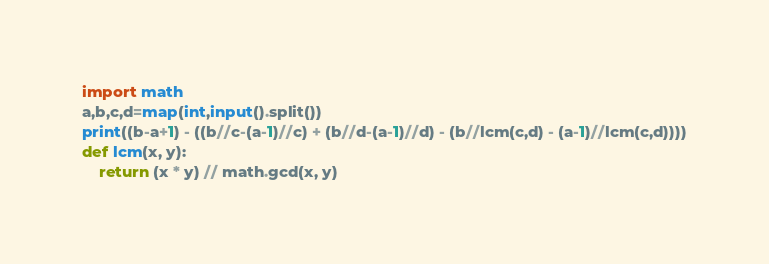<code> <loc_0><loc_0><loc_500><loc_500><_Python_>import math
a,b,c,d=map(int,input().split())
print((b-a+1) - ((b//c-(a-1)//c) + (b//d-(a-1)//d) - (b//lcm(c,d) - (a-1)//lcm(c,d))))
def lcm(x, y):
    return (x * y) // math.gcd(x, y)
</code> 